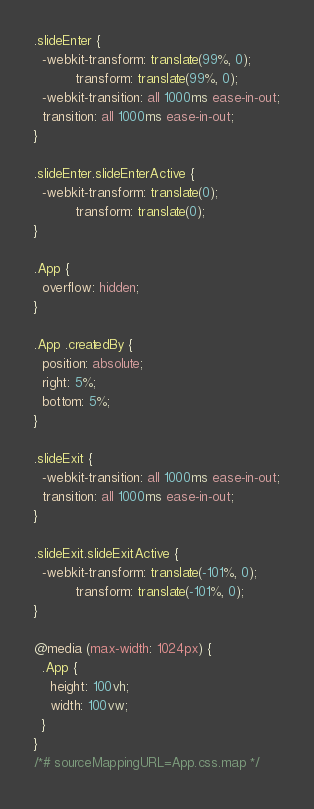<code> <loc_0><loc_0><loc_500><loc_500><_CSS_>.slideEnter {
  -webkit-transform: translate(99%, 0);
          transform: translate(99%, 0);
  -webkit-transition: all 1000ms ease-in-out;
  transition: all 1000ms ease-in-out;
}

.slideEnter.slideEnterActive {
  -webkit-transform: translate(0);
          transform: translate(0);
}

.App {
  overflow: hidden;
}

.App .createdBy {
  position: absolute;
  right: 5%;
  bottom: 5%;
}

.slideExit {
  -webkit-transition: all 1000ms ease-in-out;
  transition: all 1000ms ease-in-out;
}

.slideExit.slideExitActive {
  -webkit-transform: translate(-101%, 0);
          transform: translate(-101%, 0);
}

@media (max-width: 1024px) {
  .App {
    height: 100vh;
    width: 100vw;
  }
}
/*# sourceMappingURL=App.css.map */</code> 